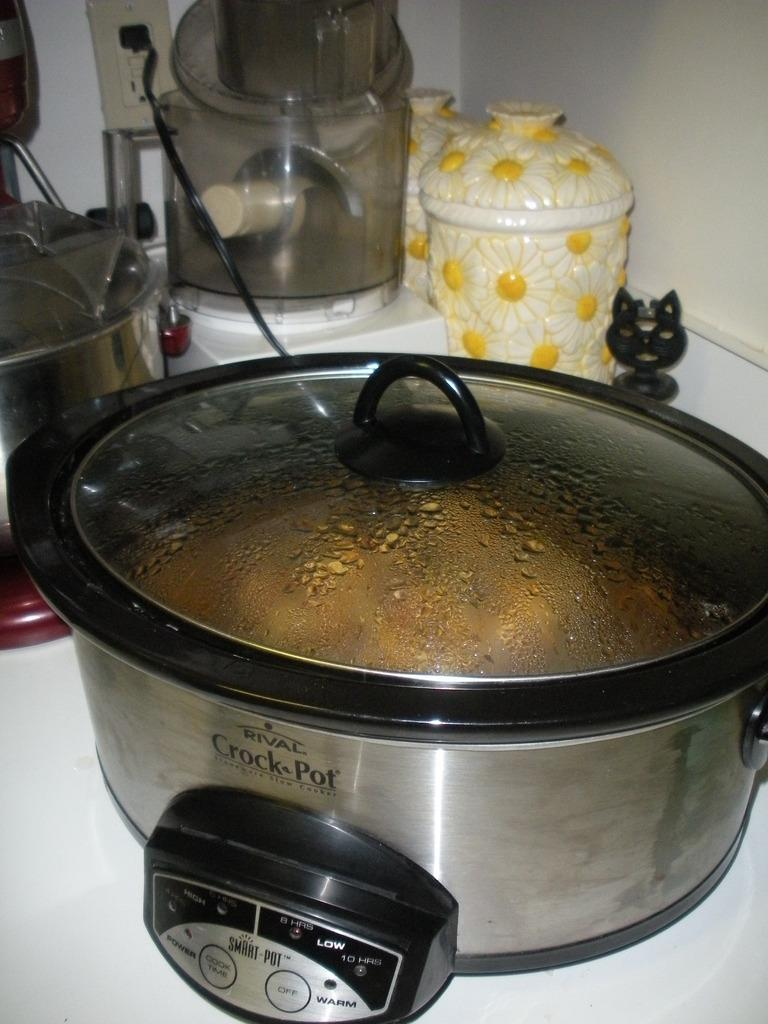<image>
Write a terse but informative summary of the picture. a close up of a Rival Crock Pot on a kitchen counter 